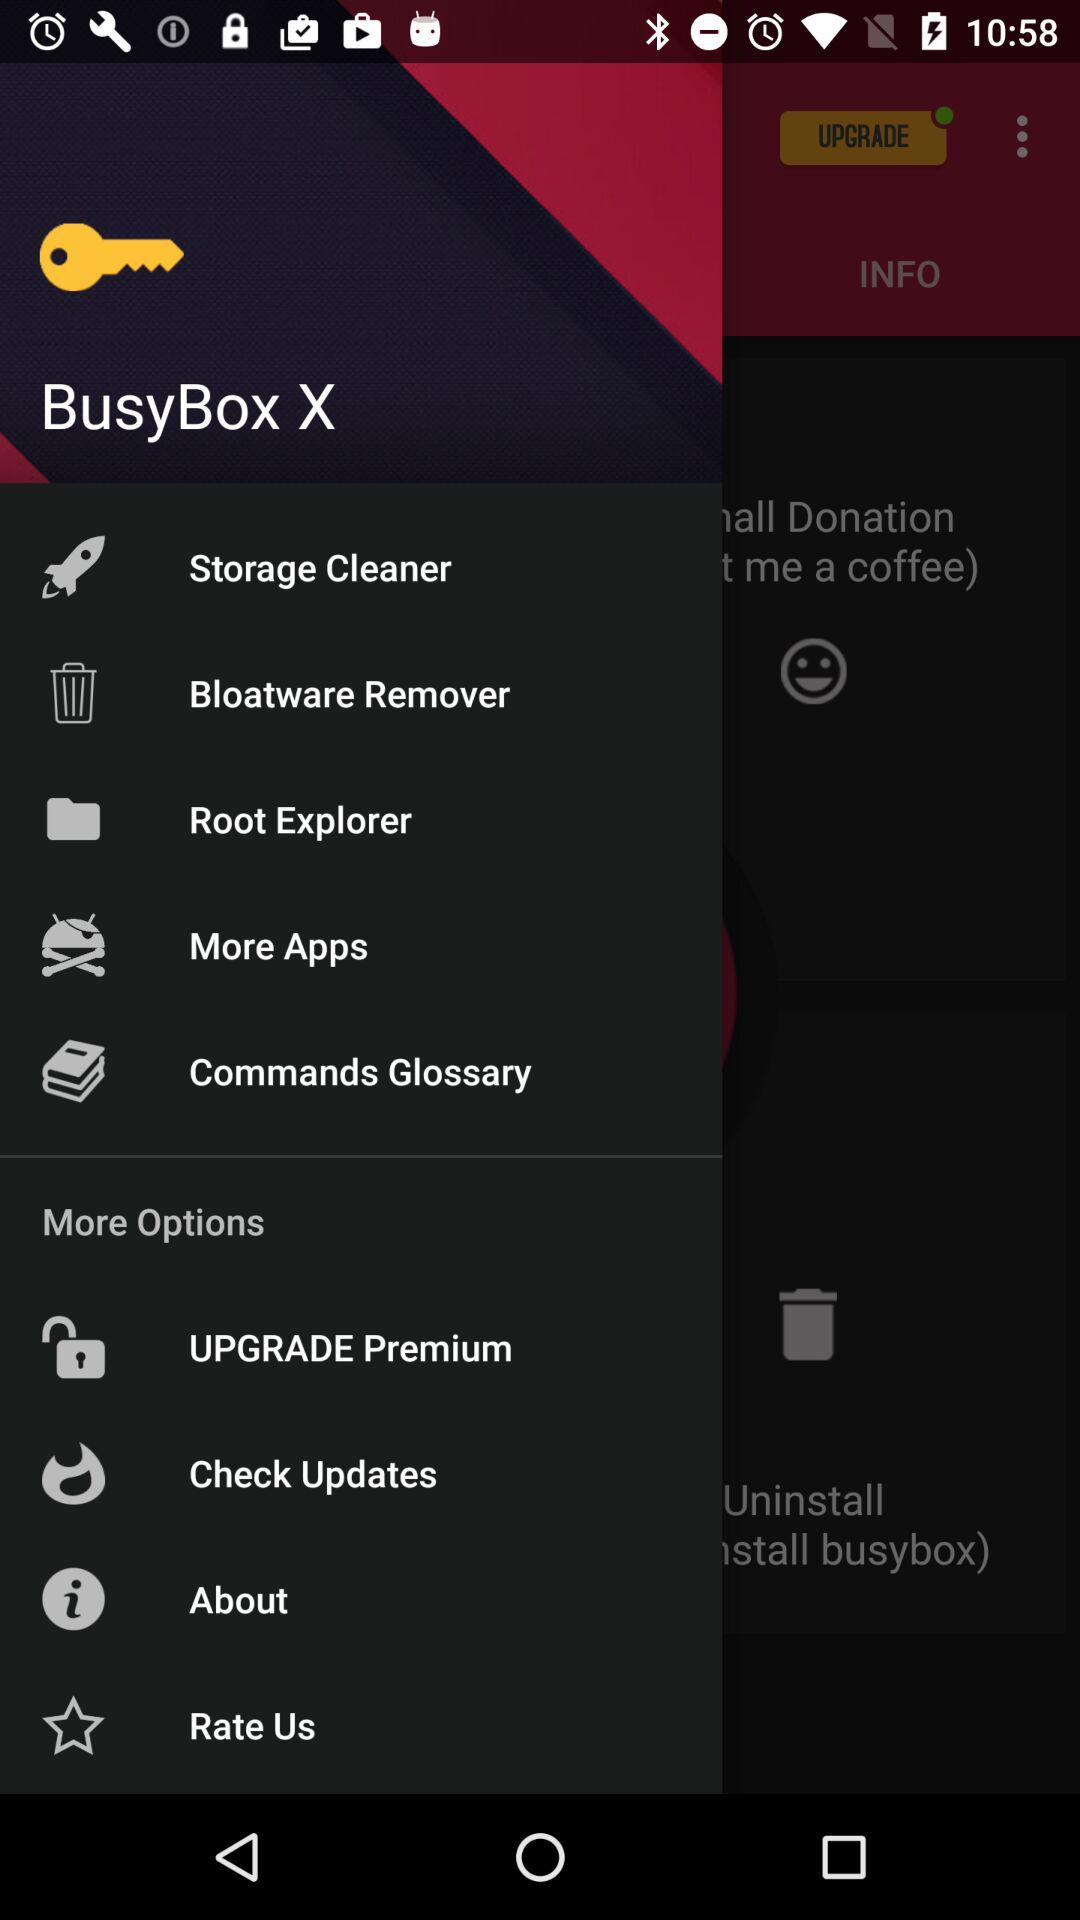What is the name of the application? The name of the application is "BusyBox X". 